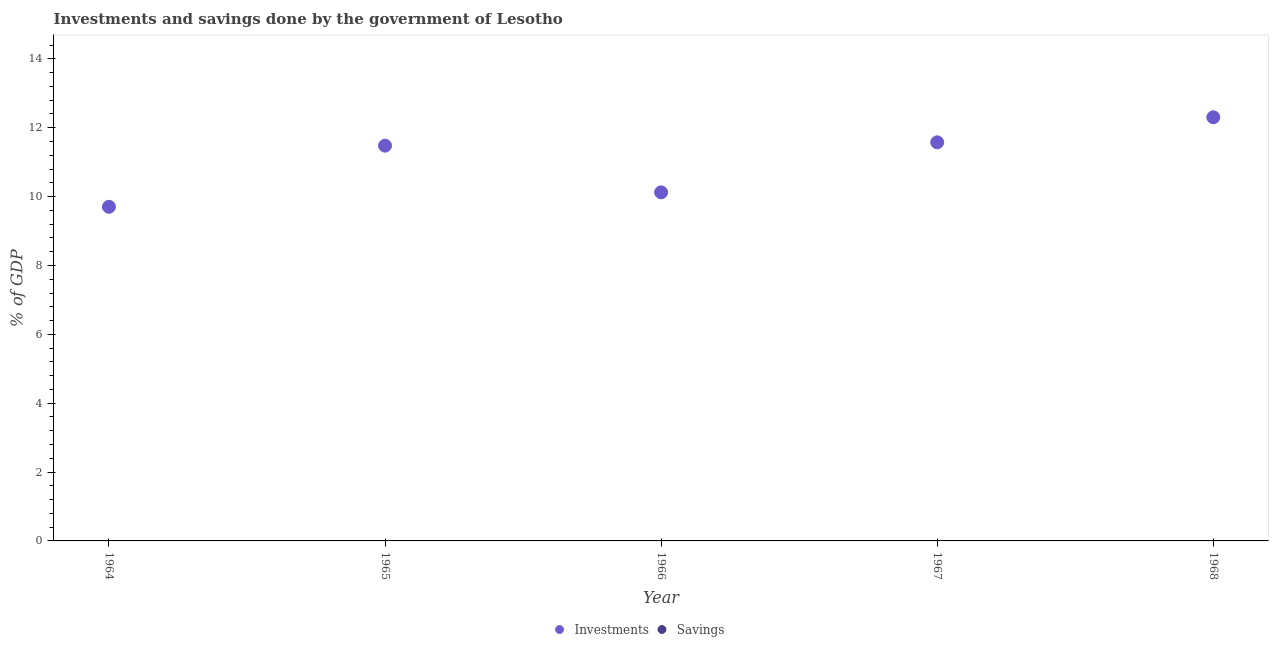Is the number of dotlines equal to the number of legend labels?
Keep it short and to the point. No. What is the investments of government in 1966?
Make the answer very short. 10.12. Across all years, what is the maximum investments of government?
Make the answer very short. 12.3. Across all years, what is the minimum investments of government?
Give a very brief answer. 9.7. In which year was the investments of government maximum?
Make the answer very short. 1968. What is the total investments of government in the graph?
Your answer should be compact. 55.19. What is the difference between the investments of government in 1964 and that in 1967?
Provide a succinct answer. -1.87. What is the difference between the investments of government in 1965 and the savings of government in 1967?
Provide a succinct answer. 11.48. In how many years, is the savings of government greater than 10.8 %?
Your answer should be compact. 0. What is the difference between the highest and the second highest investments of government?
Keep it short and to the point. 0.73. What is the difference between the highest and the lowest investments of government?
Make the answer very short. 2.6. Is the sum of the investments of government in 1966 and 1967 greater than the maximum savings of government across all years?
Your response must be concise. Yes. Is the savings of government strictly less than the investments of government over the years?
Your response must be concise. Yes. How many dotlines are there?
Ensure brevity in your answer.  1. How many years are there in the graph?
Ensure brevity in your answer.  5. Does the graph contain grids?
Provide a short and direct response. No. Where does the legend appear in the graph?
Your response must be concise. Bottom center. What is the title of the graph?
Provide a succinct answer. Investments and savings done by the government of Lesotho. Does "Taxes" appear as one of the legend labels in the graph?
Offer a very short reply. No. What is the label or title of the Y-axis?
Offer a very short reply. % of GDP. What is the % of GDP in Investments in 1964?
Provide a short and direct response. 9.7. What is the % of GDP in Investments in 1965?
Offer a very short reply. 11.48. What is the % of GDP of Investments in 1966?
Your response must be concise. 10.12. What is the % of GDP in Savings in 1966?
Your answer should be very brief. 0. What is the % of GDP in Investments in 1967?
Offer a terse response. 11.58. What is the % of GDP of Investments in 1968?
Keep it short and to the point. 12.3. What is the % of GDP in Savings in 1968?
Offer a terse response. 0. Across all years, what is the maximum % of GDP of Investments?
Provide a short and direct response. 12.3. Across all years, what is the minimum % of GDP of Investments?
Your answer should be compact. 9.7. What is the total % of GDP of Investments in the graph?
Your response must be concise. 55.19. What is the difference between the % of GDP of Investments in 1964 and that in 1965?
Offer a terse response. -1.78. What is the difference between the % of GDP in Investments in 1964 and that in 1966?
Your answer should be compact. -0.42. What is the difference between the % of GDP in Investments in 1964 and that in 1967?
Your answer should be very brief. -1.87. What is the difference between the % of GDP in Investments in 1965 and that in 1966?
Provide a succinct answer. 1.36. What is the difference between the % of GDP of Investments in 1965 and that in 1967?
Give a very brief answer. -0.1. What is the difference between the % of GDP of Investments in 1965 and that in 1968?
Your answer should be very brief. -0.82. What is the difference between the % of GDP of Investments in 1966 and that in 1967?
Provide a short and direct response. -1.45. What is the difference between the % of GDP in Investments in 1966 and that in 1968?
Your answer should be compact. -2.18. What is the difference between the % of GDP of Investments in 1967 and that in 1968?
Offer a terse response. -0.73. What is the average % of GDP of Investments per year?
Provide a short and direct response. 11.04. What is the average % of GDP of Savings per year?
Provide a succinct answer. 0. What is the ratio of the % of GDP of Investments in 1964 to that in 1965?
Your answer should be very brief. 0.85. What is the ratio of the % of GDP of Investments in 1964 to that in 1966?
Ensure brevity in your answer.  0.96. What is the ratio of the % of GDP of Investments in 1964 to that in 1967?
Ensure brevity in your answer.  0.84. What is the ratio of the % of GDP of Investments in 1964 to that in 1968?
Keep it short and to the point. 0.79. What is the ratio of the % of GDP of Investments in 1965 to that in 1966?
Give a very brief answer. 1.13. What is the ratio of the % of GDP of Investments in 1965 to that in 1967?
Your answer should be very brief. 0.99. What is the ratio of the % of GDP in Investments in 1965 to that in 1968?
Provide a short and direct response. 0.93. What is the ratio of the % of GDP in Investments in 1966 to that in 1967?
Keep it short and to the point. 0.87. What is the ratio of the % of GDP of Investments in 1966 to that in 1968?
Make the answer very short. 0.82. What is the ratio of the % of GDP in Investments in 1967 to that in 1968?
Offer a terse response. 0.94. What is the difference between the highest and the second highest % of GDP of Investments?
Your response must be concise. 0.73. What is the difference between the highest and the lowest % of GDP of Investments?
Provide a short and direct response. 2.6. 